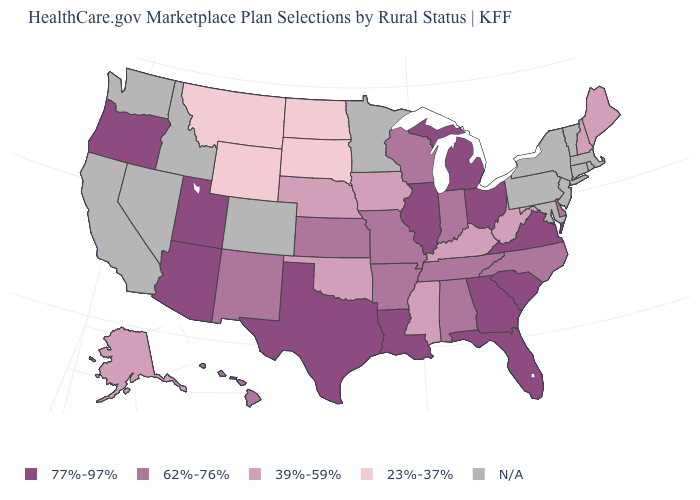What is the highest value in the West ?
Give a very brief answer. 77%-97%. Name the states that have a value in the range 39%-59%?
Answer briefly. Alaska, Iowa, Kentucky, Maine, Mississippi, Nebraska, New Hampshire, Oklahoma, West Virginia. What is the value of South Carolina?
Give a very brief answer. 77%-97%. What is the lowest value in the USA?
Keep it brief. 23%-37%. Does the map have missing data?
Answer briefly. Yes. Which states have the lowest value in the South?
Write a very short answer. Kentucky, Mississippi, Oklahoma, West Virginia. Does Missouri have the highest value in the USA?
Give a very brief answer. No. Does Texas have the lowest value in the USA?
Write a very short answer. No. What is the value of Arizona?
Answer briefly. 77%-97%. Is the legend a continuous bar?
Keep it brief. No. Does the map have missing data?
Short answer required. Yes. Name the states that have a value in the range 77%-97%?
Answer briefly. Arizona, Florida, Georgia, Illinois, Louisiana, Michigan, Ohio, Oregon, South Carolina, Texas, Utah, Virginia. What is the value of Oklahoma?
Short answer required. 39%-59%. 